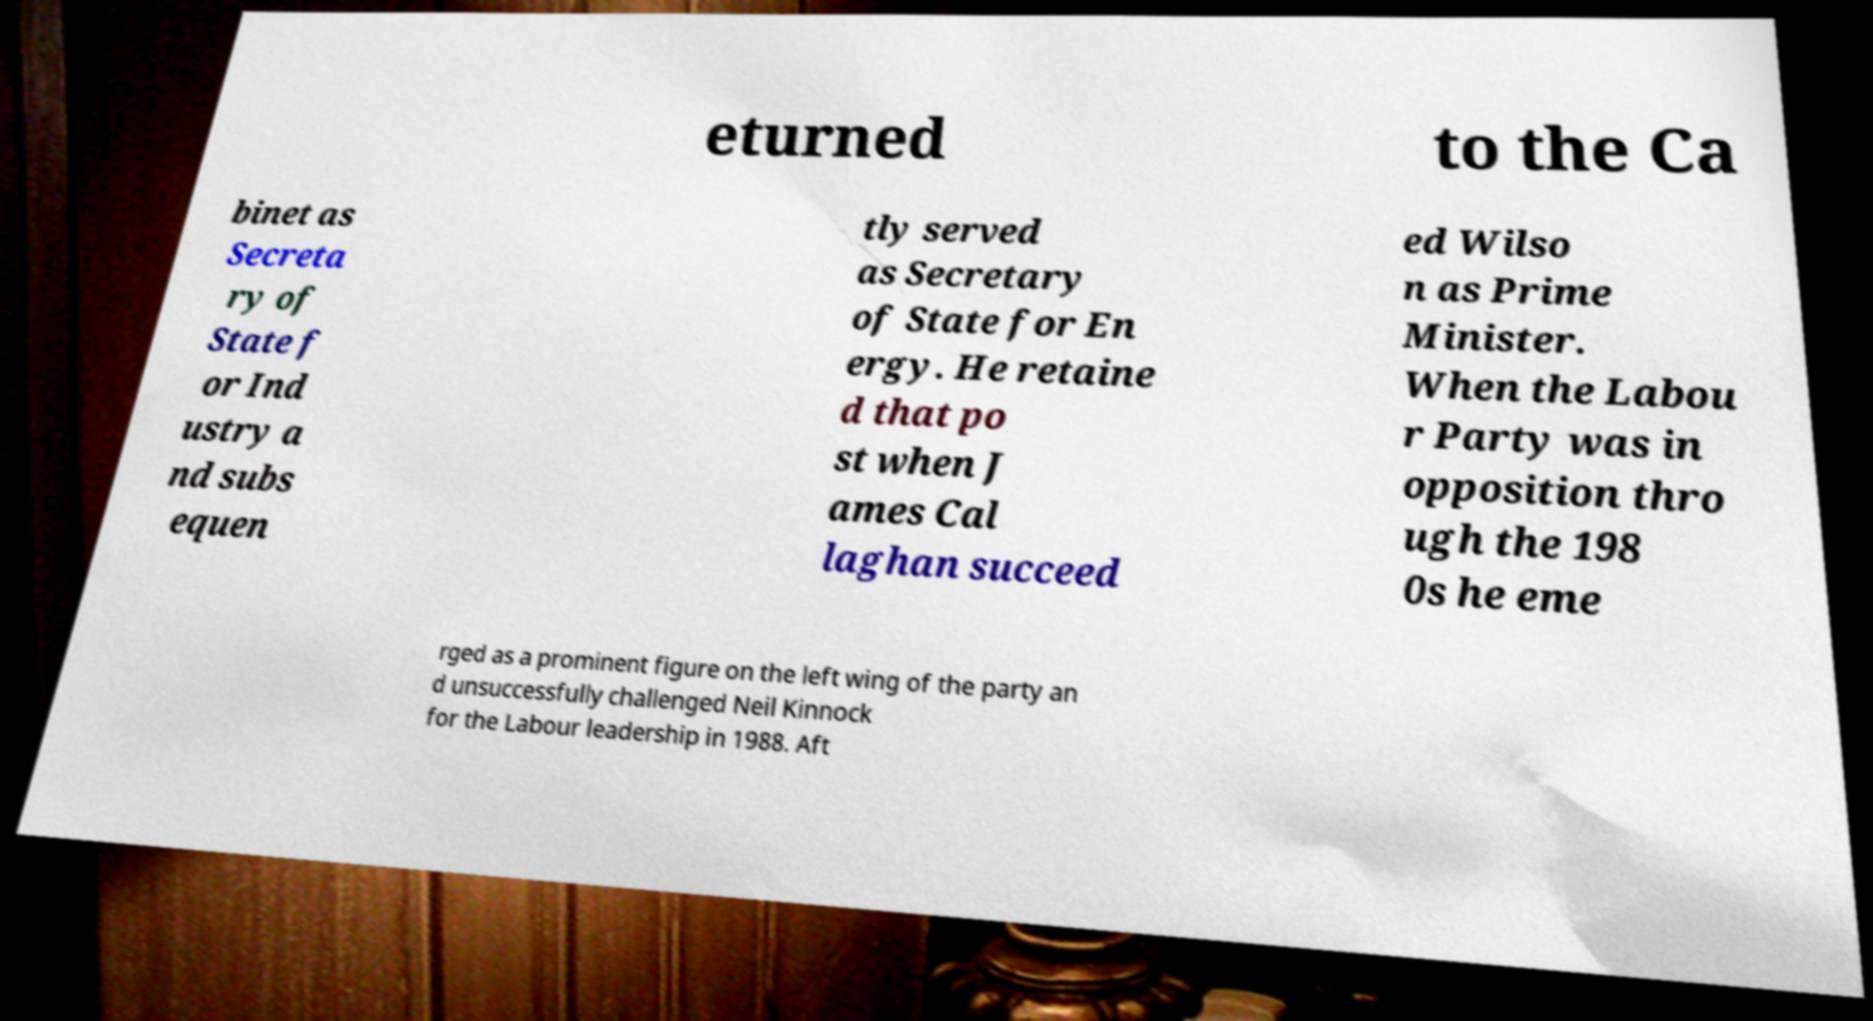There's text embedded in this image that I need extracted. Can you transcribe it verbatim? eturned to the Ca binet as Secreta ry of State f or Ind ustry a nd subs equen tly served as Secretary of State for En ergy. He retaine d that po st when J ames Cal laghan succeed ed Wilso n as Prime Minister. When the Labou r Party was in opposition thro ugh the 198 0s he eme rged as a prominent figure on the left wing of the party an d unsuccessfully challenged Neil Kinnock for the Labour leadership in 1988. Aft 